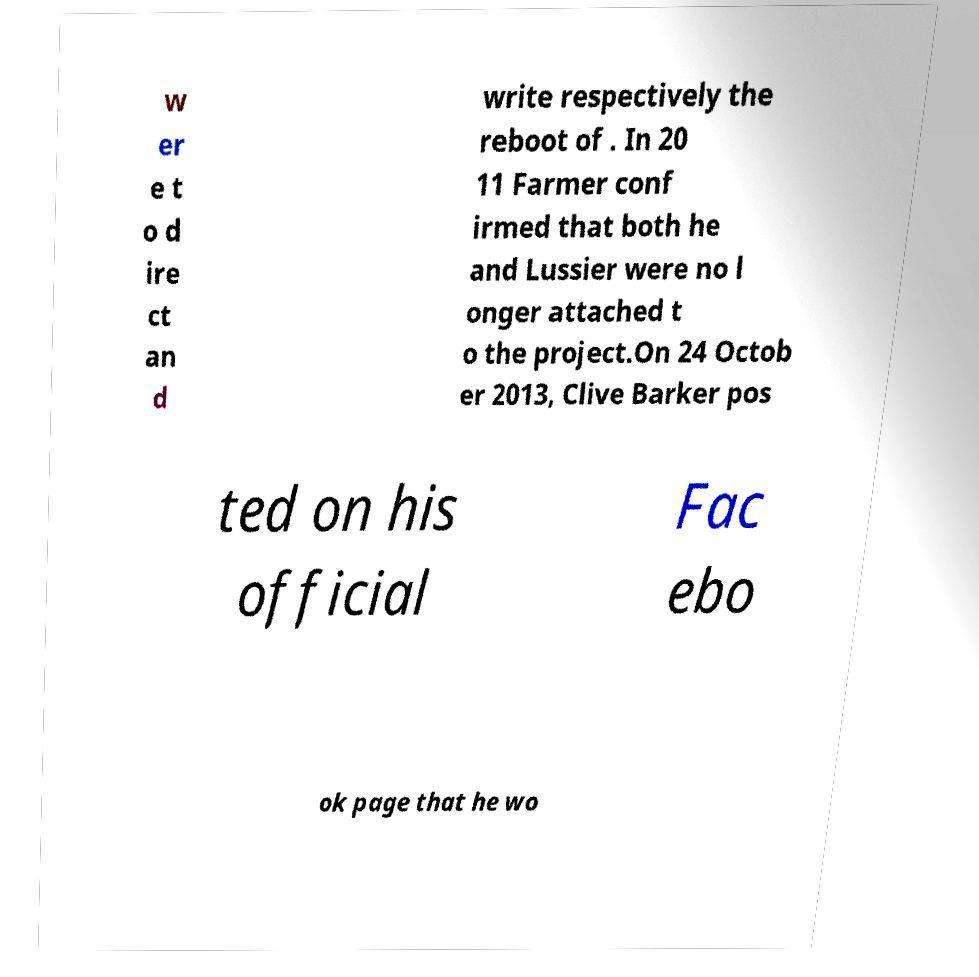For documentation purposes, I need the text within this image transcribed. Could you provide that? w er e t o d ire ct an d write respectively the reboot of . In 20 11 Farmer conf irmed that both he and Lussier were no l onger attached t o the project.On 24 Octob er 2013, Clive Barker pos ted on his official Fac ebo ok page that he wo 